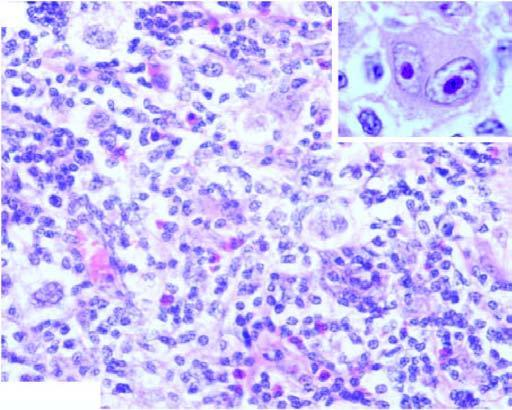what are there of collagen forming nodules and characteristic lacunar rs cells?
Answer the question using a single word or phrase. Bands 